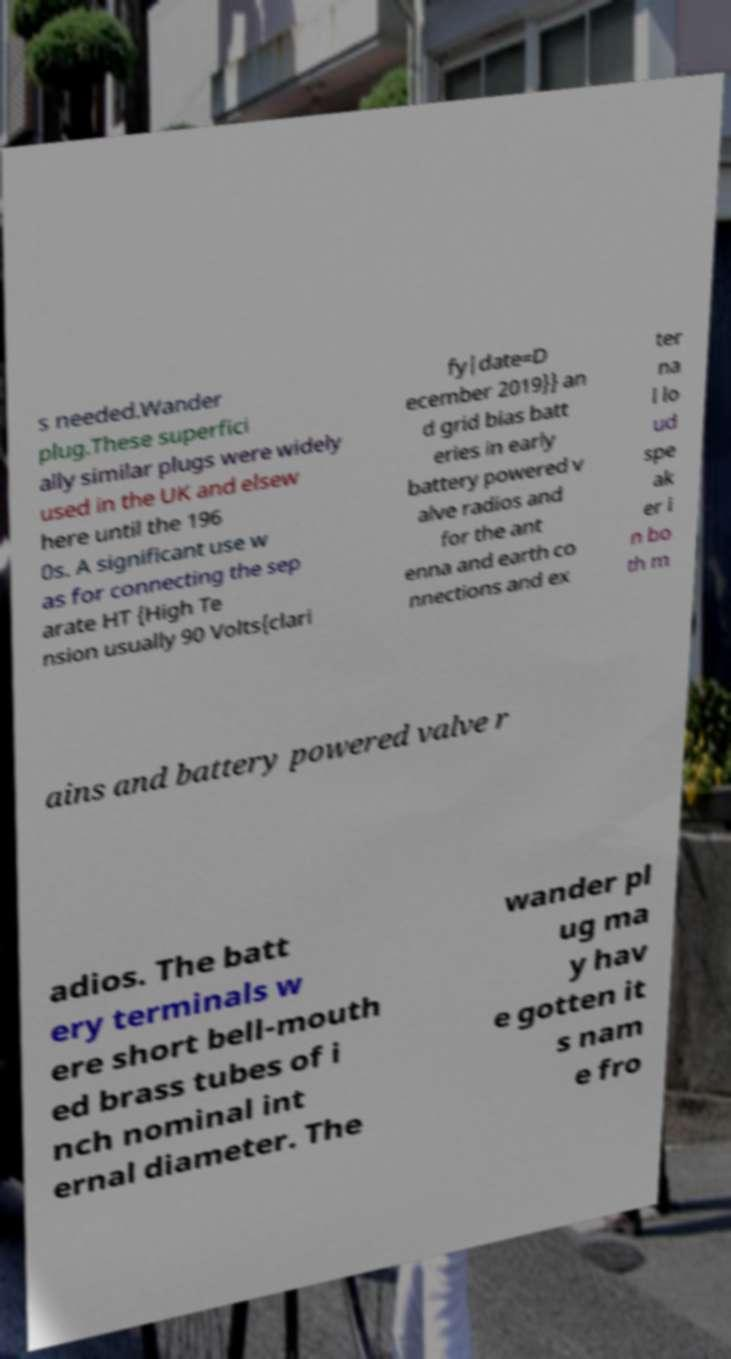Please identify and transcribe the text found in this image. s needed.Wander plug.These superfici ally similar plugs were widely used in the UK and elsew here until the 196 0s. A significant use w as for connecting the sep arate HT {High Te nsion usually 90 Volts{clari fy|date=D ecember 2019}} an d grid bias batt eries in early battery powered v alve radios and for the ant enna and earth co nnections and ex ter na l lo ud spe ak er i n bo th m ains and battery powered valve r adios. The batt ery terminals w ere short bell-mouth ed brass tubes of i nch nominal int ernal diameter. The wander pl ug ma y hav e gotten it s nam e fro 